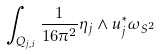<formula> <loc_0><loc_0><loc_500><loc_500>\int _ { Q _ { j , i } } \frac { 1 } { 1 6 \pi ^ { 2 } } \eta _ { j } \wedge u ^ { * } _ { j } \omega _ { S ^ { 2 } }</formula> 